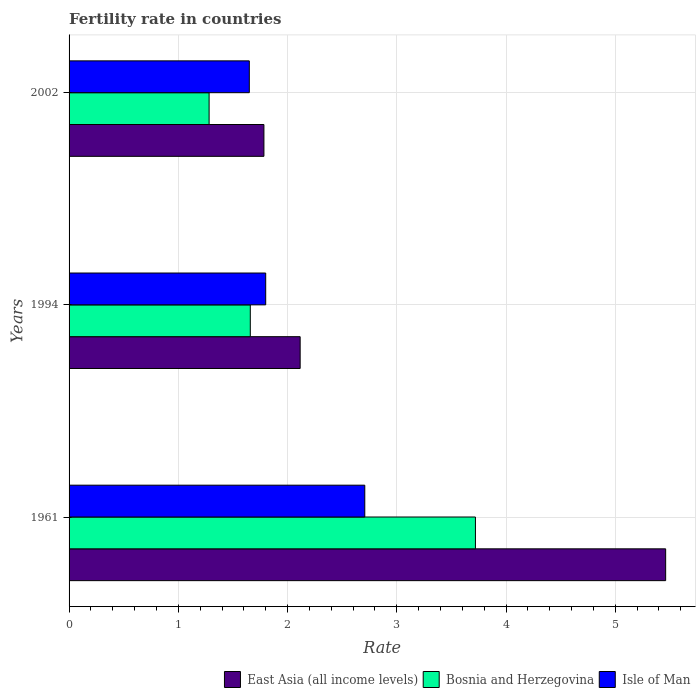How many different coloured bars are there?
Your response must be concise. 3. How many groups of bars are there?
Your answer should be very brief. 3. Are the number of bars on each tick of the Y-axis equal?
Your answer should be very brief. Yes. What is the fertility rate in Bosnia and Herzegovina in 1994?
Your response must be concise. 1.66. Across all years, what is the maximum fertility rate in Isle of Man?
Ensure brevity in your answer.  2.71. Across all years, what is the minimum fertility rate in East Asia (all income levels)?
Your answer should be very brief. 1.78. In which year was the fertility rate in Bosnia and Herzegovina maximum?
Your answer should be very brief. 1961. What is the total fertility rate in East Asia (all income levels) in the graph?
Offer a very short reply. 9.36. What is the difference between the fertility rate in East Asia (all income levels) in 1961 and that in 2002?
Provide a short and direct response. 3.68. What is the difference between the fertility rate in East Asia (all income levels) in 1994 and the fertility rate in Isle of Man in 1961?
Provide a short and direct response. -0.59. What is the average fertility rate in Isle of Man per year?
Your answer should be very brief. 2.05. In the year 1961, what is the difference between the fertility rate in East Asia (all income levels) and fertility rate in Isle of Man?
Give a very brief answer. 2.75. What is the ratio of the fertility rate in East Asia (all income levels) in 1961 to that in 2002?
Offer a terse response. 3.06. What is the difference between the highest and the second highest fertility rate in Bosnia and Herzegovina?
Your answer should be compact. 2.06. What is the difference between the highest and the lowest fertility rate in East Asia (all income levels)?
Your answer should be compact. 3.68. In how many years, is the fertility rate in East Asia (all income levels) greater than the average fertility rate in East Asia (all income levels) taken over all years?
Offer a terse response. 1. What does the 1st bar from the top in 1994 represents?
Your response must be concise. Isle of Man. What does the 1st bar from the bottom in 1994 represents?
Your answer should be compact. East Asia (all income levels). Is it the case that in every year, the sum of the fertility rate in East Asia (all income levels) and fertility rate in Isle of Man is greater than the fertility rate in Bosnia and Herzegovina?
Your answer should be very brief. Yes. How many bars are there?
Offer a very short reply. 9. Are all the bars in the graph horizontal?
Provide a short and direct response. Yes. How many years are there in the graph?
Ensure brevity in your answer.  3. Are the values on the major ticks of X-axis written in scientific E-notation?
Offer a terse response. No. How are the legend labels stacked?
Your response must be concise. Horizontal. What is the title of the graph?
Ensure brevity in your answer.  Fertility rate in countries. Does "Europe(all income levels)" appear as one of the legend labels in the graph?
Your answer should be compact. No. What is the label or title of the X-axis?
Offer a very short reply. Rate. What is the Rate of East Asia (all income levels) in 1961?
Your response must be concise. 5.46. What is the Rate in Bosnia and Herzegovina in 1961?
Provide a succinct answer. 3.72. What is the Rate in Isle of Man in 1961?
Make the answer very short. 2.71. What is the Rate of East Asia (all income levels) in 1994?
Keep it short and to the point. 2.12. What is the Rate in Bosnia and Herzegovina in 1994?
Keep it short and to the point. 1.66. What is the Rate of East Asia (all income levels) in 2002?
Your response must be concise. 1.78. What is the Rate in Bosnia and Herzegovina in 2002?
Give a very brief answer. 1.28. What is the Rate in Isle of Man in 2002?
Provide a succinct answer. 1.65. Across all years, what is the maximum Rate of East Asia (all income levels)?
Your response must be concise. 5.46. Across all years, what is the maximum Rate in Bosnia and Herzegovina?
Provide a short and direct response. 3.72. Across all years, what is the maximum Rate in Isle of Man?
Make the answer very short. 2.71. Across all years, what is the minimum Rate of East Asia (all income levels)?
Offer a very short reply. 1.78. Across all years, what is the minimum Rate of Bosnia and Herzegovina?
Offer a terse response. 1.28. Across all years, what is the minimum Rate of Isle of Man?
Offer a terse response. 1.65. What is the total Rate of East Asia (all income levels) in the graph?
Your response must be concise. 9.36. What is the total Rate of Bosnia and Herzegovina in the graph?
Give a very brief answer. 6.66. What is the total Rate of Isle of Man in the graph?
Your answer should be compact. 6.16. What is the difference between the Rate in East Asia (all income levels) in 1961 and that in 1994?
Provide a succinct answer. 3.35. What is the difference between the Rate of Bosnia and Herzegovina in 1961 and that in 1994?
Your answer should be very brief. 2.06. What is the difference between the Rate in Isle of Man in 1961 and that in 1994?
Your answer should be very brief. 0.91. What is the difference between the Rate in East Asia (all income levels) in 1961 and that in 2002?
Provide a short and direct response. 3.68. What is the difference between the Rate of Bosnia and Herzegovina in 1961 and that in 2002?
Your answer should be very brief. 2.44. What is the difference between the Rate in Isle of Man in 1961 and that in 2002?
Make the answer very short. 1.06. What is the difference between the Rate in East Asia (all income levels) in 1994 and that in 2002?
Your response must be concise. 0.33. What is the difference between the Rate of Bosnia and Herzegovina in 1994 and that in 2002?
Offer a very short reply. 0.38. What is the difference between the Rate of Isle of Man in 1994 and that in 2002?
Ensure brevity in your answer.  0.15. What is the difference between the Rate in East Asia (all income levels) in 1961 and the Rate in Bosnia and Herzegovina in 1994?
Your answer should be compact. 3.8. What is the difference between the Rate in East Asia (all income levels) in 1961 and the Rate in Isle of Man in 1994?
Offer a very short reply. 3.66. What is the difference between the Rate of Bosnia and Herzegovina in 1961 and the Rate of Isle of Man in 1994?
Keep it short and to the point. 1.92. What is the difference between the Rate in East Asia (all income levels) in 1961 and the Rate in Bosnia and Herzegovina in 2002?
Your answer should be very brief. 4.18. What is the difference between the Rate in East Asia (all income levels) in 1961 and the Rate in Isle of Man in 2002?
Your answer should be very brief. 3.81. What is the difference between the Rate of Bosnia and Herzegovina in 1961 and the Rate of Isle of Man in 2002?
Your answer should be compact. 2.07. What is the difference between the Rate of East Asia (all income levels) in 1994 and the Rate of Bosnia and Herzegovina in 2002?
Offer a terse response. 0.83. What is the difference between the Rate in East Asia (all income levels) in 1994 and the Rate in Isle of Man in 2002?
Your answer should be very brief. 0.47. What is the difference between the Rate of Bosnia and Herzegovina in 1994 and the Rate of Isle of Man in 2002?
Offer a terse response. 0.01. What is the average Rate in East Asia (all income levels) per year?
Provide a short and direct response. 3.12. What is the average Rate of Bosnia and Herzegovina per year?
Make the answer very short. 2.22. What is the average Rate of Isle of Man per year?
Keep it short and to the point. 2.05. In the year 1961, what is the difference between the Rate of East Asia (all income levels) and Rate of Bosnia and Herzegovina?
Provide a short and direct response. 1.74. In the year 1961, what is the difference between the Rate of East Asia (all income levels) and Rate of Isle of Man?
Keep it short and to the point. 2.75. In the year 1961, what is the difference between the Rate in Bosnia and Herzegovina and Rate in Isle of Man?
Give a very brief answer. 1.01. In the year 1994, what is the difference between the Rate in East Asia (all income levels) and Rate in Bosnia and Herzegovina?
Give a very brief answer. 0.46. In the year 1994, what is the difference between the Rate in East Asia (all income levels) and Rate in Isle of Man?
Make the answer very short. 0.32. In the year 1994, what is the difference between the Rate in Bosnia and Herzegovina and Rate in Isle of Man?
Your answer should be very brief. -0.14. In the year 2002, what is the difference between the Rate of East Asia (all income levels) and Rate of Bosnia and Herzegovina?
Ensure brevity in your answer.  0.5. In the year 2002, what is the difference between the Rate of East Asia (all income levels) and Rate of Isle of Man?
Make the answer very short. 0.13. In the year 2002, what is the difference between the Rate of Bosnia and Herzegovina and Rate of Isle of Man?
Your answer should be compact. -0.37. What is the ratio of the Rate in East Asia (all income levels) in 1961 to that in 1994?
Ensure brevity in your answer.  2.58. What is the ratio of the Rate of Bosnia and Herzegovina in 1961 to that in 1994?
Keep it short and to the point. 2.24. What is the ratio of the Rate of Isle of Man in 1961 to that in 1994?
Give a very brief answer. 1.5. What is the ratio of the Rate in East Asia (all income levels) in 1961 to that in 2002?
Provide a succinct answer. 3.06. What is the ratio of the Rate of Bosnia and Herzegovina in 1961 to that in 2002?
Offer a very short reply. 2.9. What is the ratio of the Rate of Isle of Man in 1961 to that in 2002?
Make the answer very short. 1.64. What is the ratio of the Rate of East Asia (all income levels) in 1994 to that in 2002?
Offer a terse response. 1.19. What is the ratio of the Rate in Bosnia and Herzegovina in 1994 to that in 2002?
Offer a very short reply. 1.29. What is the ratio of the Rate in Isle of Man in 1994 to that in 2002?
Offer a terse response. 1.09. What is the difference between the highest and the second highest Rate of East Asia (all income levels)?
Keep it short and to the point. 3.35. What is the difference between the highest and the second highest Rate in Bosnia and Herzegovina?
Provide a succinct answer. 2.06. What is the difference between the highest and the second highest Rate in Isle of Man?
Give a very brief answer. 0.91. What is the difference between the highest and the lowest Rate of East Asia (all income levels)?
Keep it short and to the point. 3.68. What is the difference between the highest and the lowest Rate in Bosnia and Herzegovina?
Offer a very short reply. 2.44. What is the difference between the highest and the lowest Rate of Isle of Man?
Make the answer very short. 1.06. 